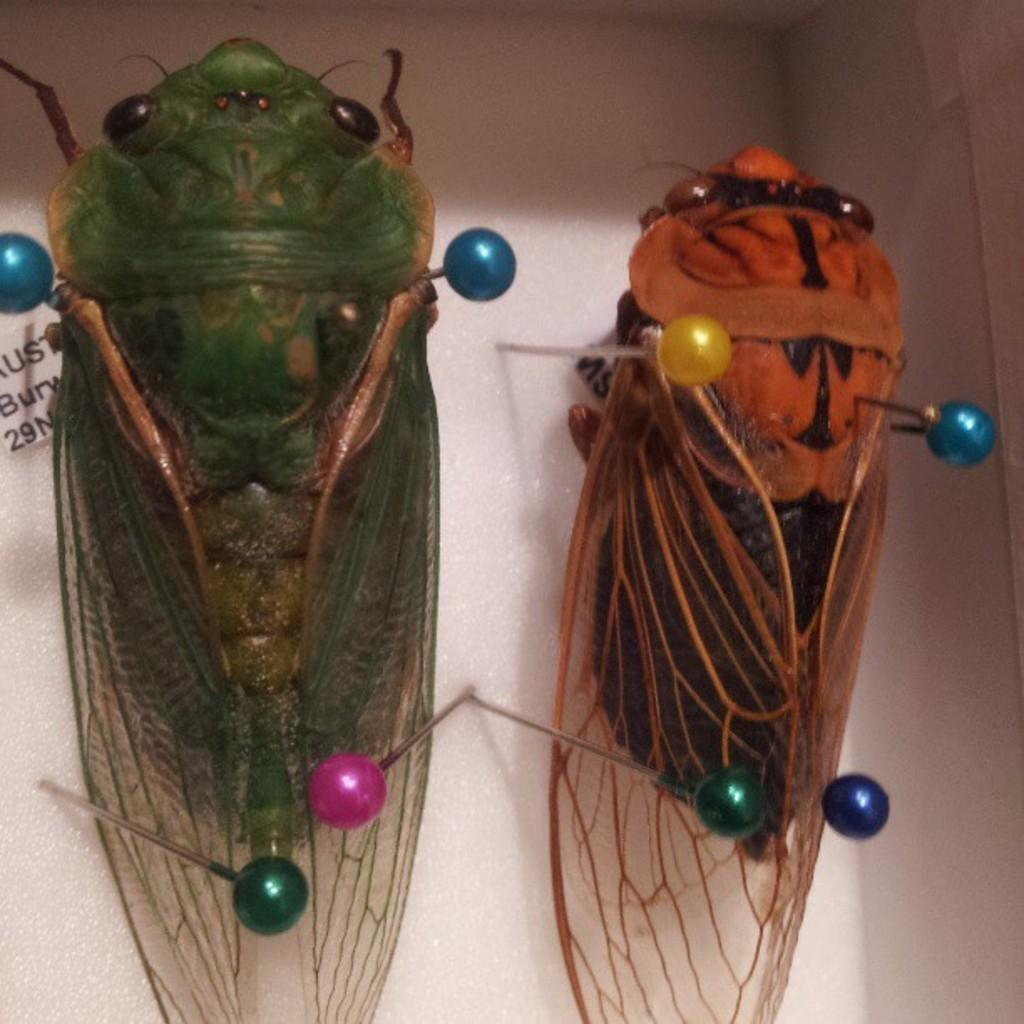What type of creatures can be seen in the image? There are insects in the image. What objects are also present in the image? There are ball pins in the image. What is the color of the surface in the image? The surface in the image is white. What type of comfort can be seen in the image? There is no reference to comfort in the image; it features insects and ball pins on a white surface. 